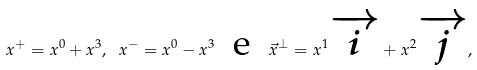<formula> <loc_0><loc_0><loc_500><loc_500>x ^ { + } = x ^ { 0 } + x ^ { 3 } , \text { } x ^ { - } = x ^ { 0 } - x ^ { 3 } \text { \ e \ } \vec { x } ^ { \perp } = x ^ { 1 } \overrightarrow { i } + x ^ { 2 } \overrightarrow { j } ,</formula> 